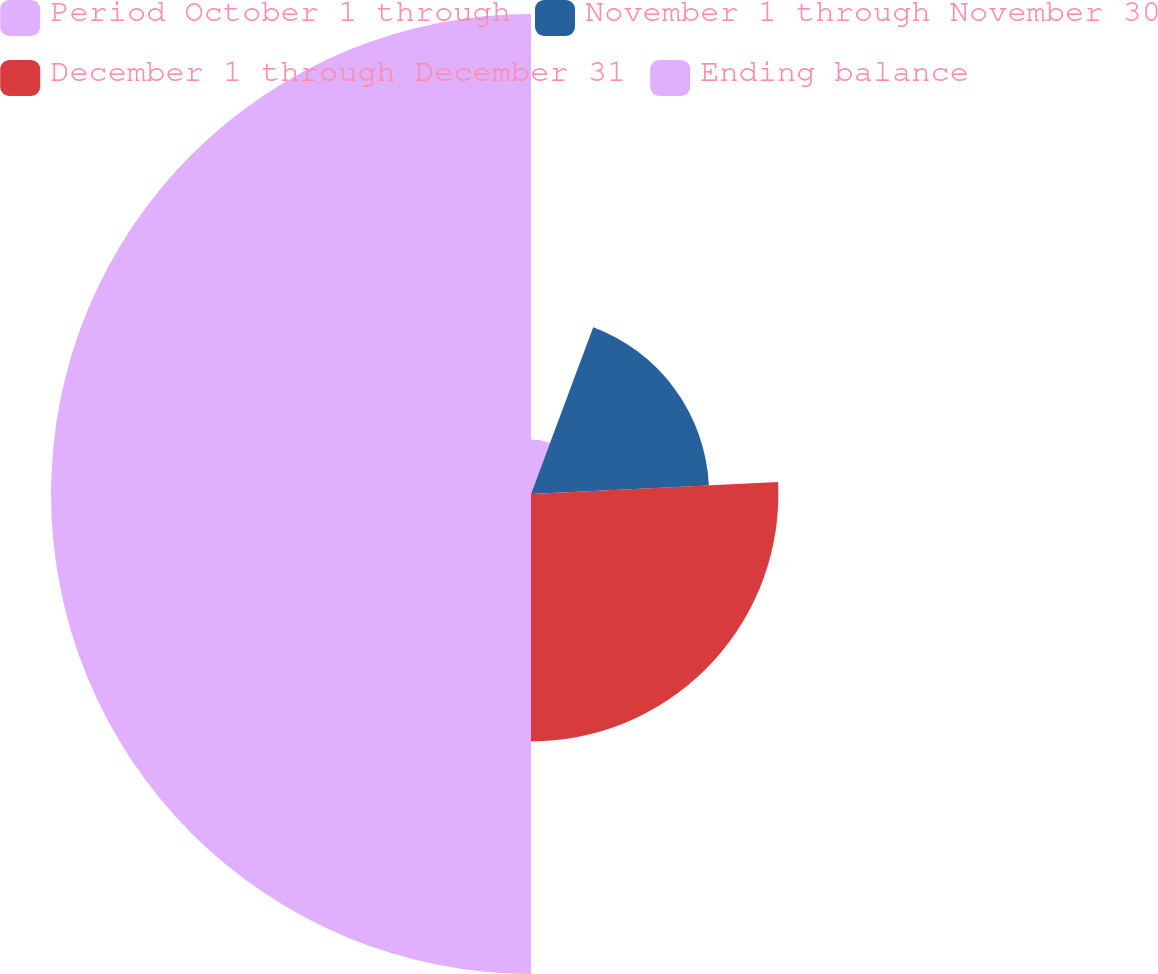<chart> <loc_0><loc_0><loc_500><loc_500><pie_chart><fcel>Period October 1 through<fcel>November 1 through November 30<fcel>December 1 through December 31<fcel>Ending balance<nl><fcel>5.68%<fcel>18.55%<fcel>25.77%<fcel>50.0%<nl></chart> 